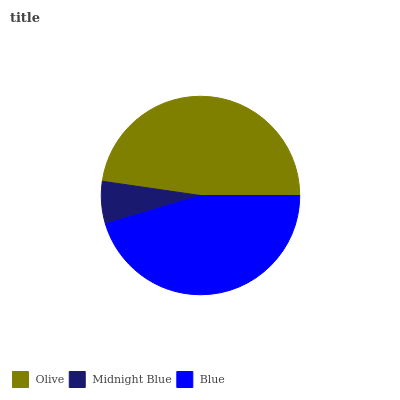Is Midnight Blue the minimum?
Answer yes or no. Yes. Is Olive the maximum?
Answer yes or no. Yes. Is Blue the minimum?
Answer yes or no. No. Is Blue the maximum?
Answer yes or no. No. Is Blue greater than Midnight Blue?
Answer yes or no. Yes. Is Midnight Blue less than Blue?
Answer yes or no. Yes. Is Midnight Blue greater than Blue?
Answer yes or no. No. Is Blue less than Midnight Blue?
Answer yes or no. No. Is Blue the high median?
Answer yes or no. Yes. Is Blue the low median?
Answer yes or no. Yes. Is Midnight Blue the high median?
Answer yes or no. No. Is Olive the low median?
Answer yes or no. No. 